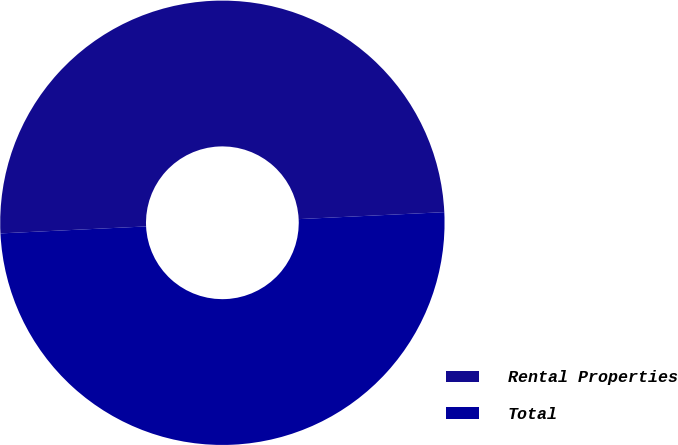<chart> <loc_0><loc_0><loc_500><loc_500><pie_chart><fcel>Rental Properties<fcel>Total<nl><fcel>50.0%<fcel>50.0%<nl></chart> 